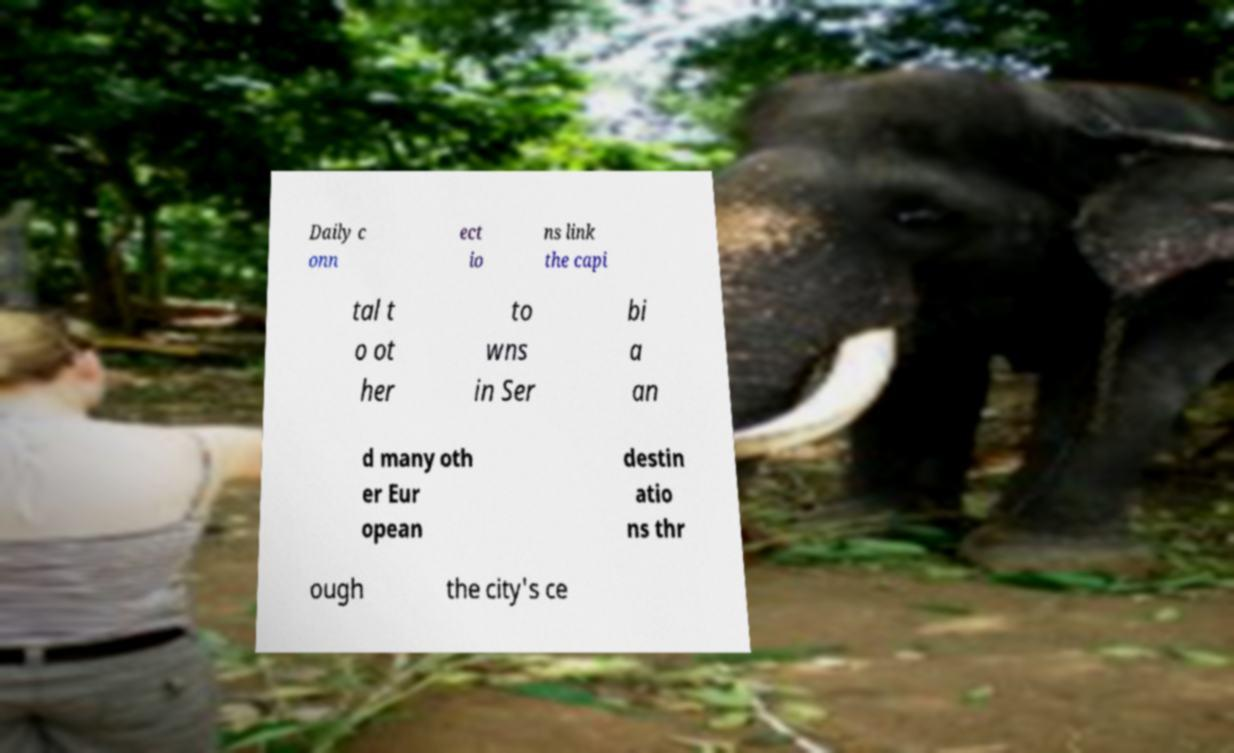Please read and relay the text visible in this image. What does it say? Daily c onn ect io ns link the capi tal t o ot her to wns in Ser bi a an d many oth er Eur opean destin atio ns thr ough the city's ce 